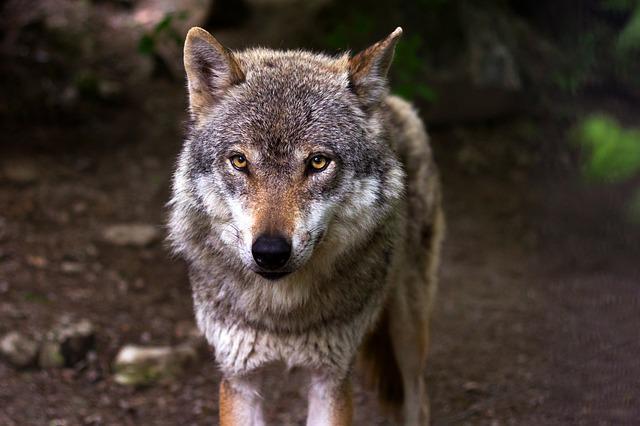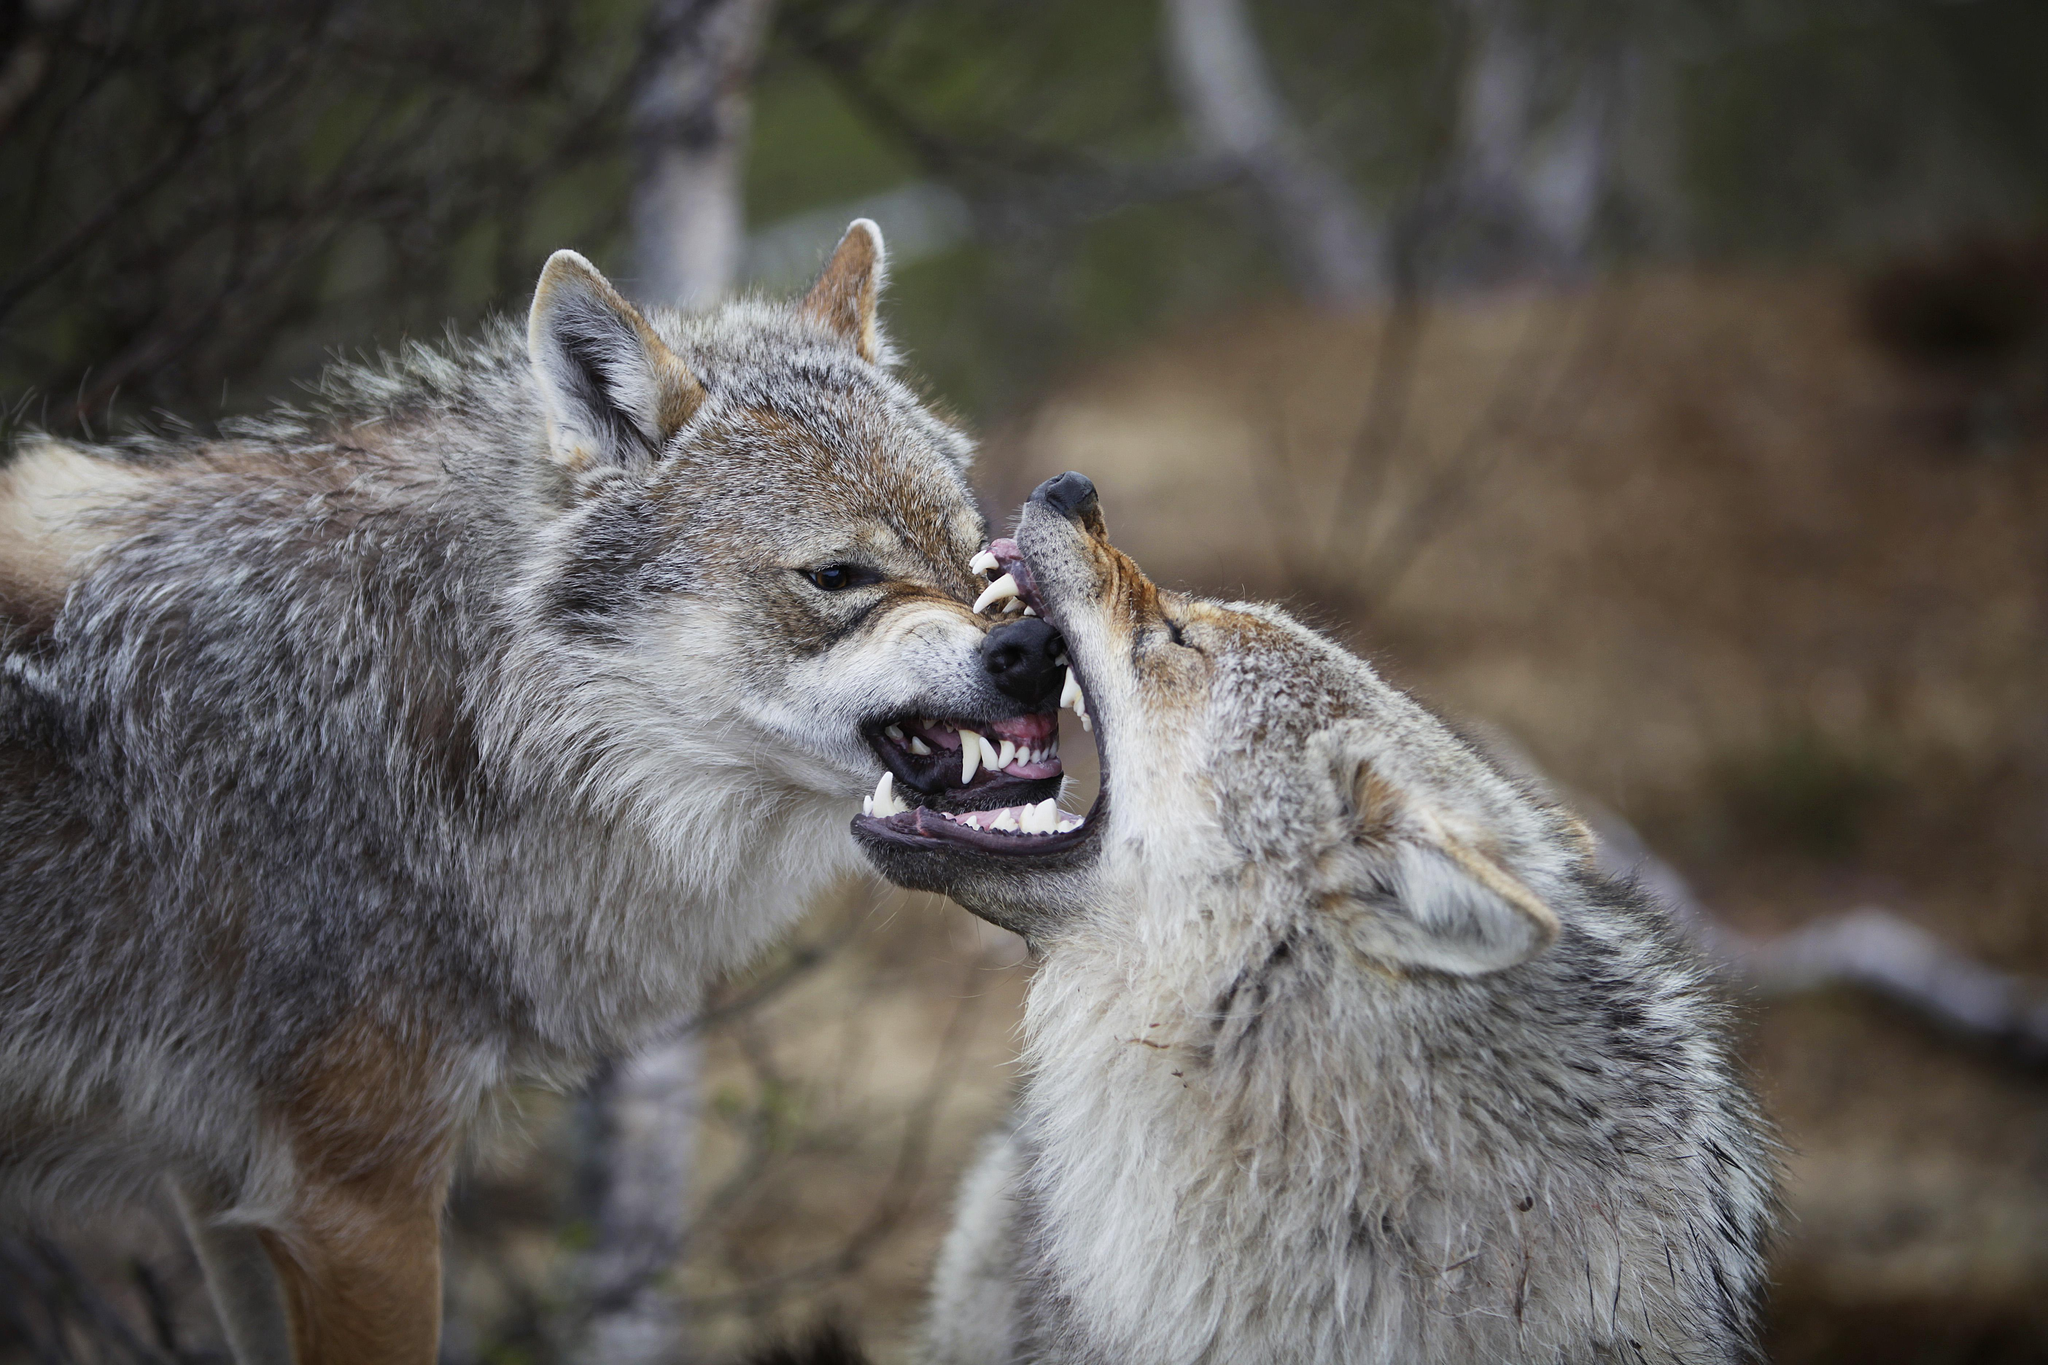The first image is the image on the left, the second image is the image on the right. Given the left and right images, does the statement "Both images contain a hunter posing with a dead wolf." hold true? Answer yes or no. No. The first image is the image on the left, the second image is the image on the right. Analyze the images presented: Is the assertion "One image shows a nonstanding person posed behind a reclining wolf, and the other other image shows a standing person with arms holding up a wolf." valid? Answer yes or no. No. 